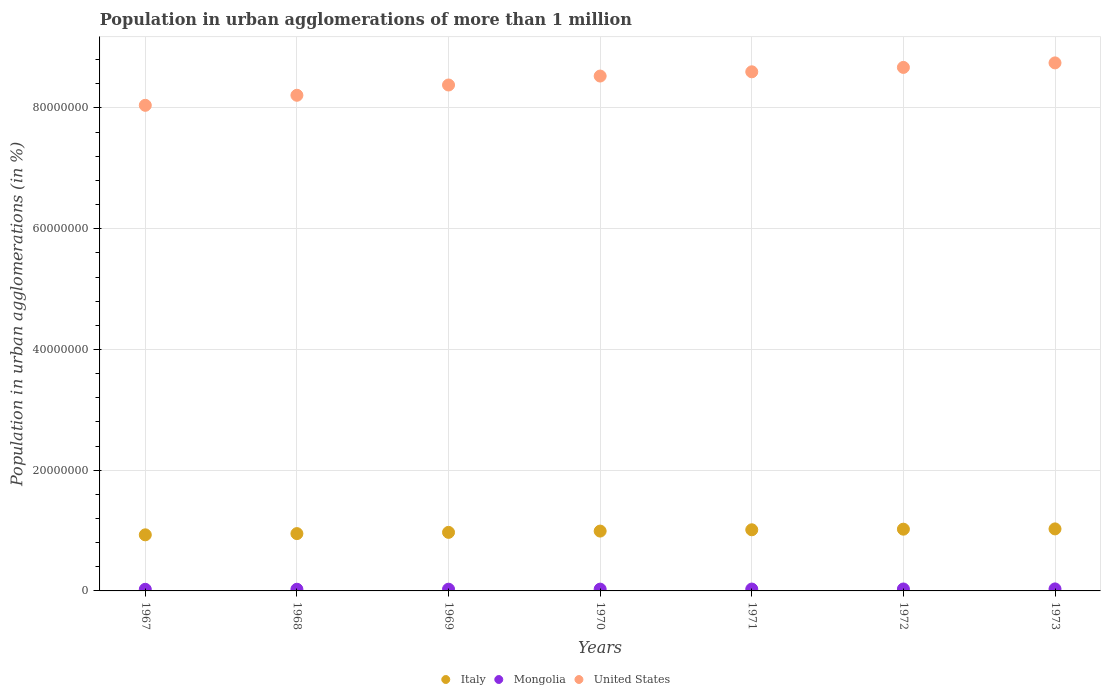Is the number of dotlines equal to the number of legend labels?
Keep it short and to the point. Yes. What is the population in urban agglomerations in United States in 1969?
Offer a very short reply. 8.38e+07. Across all years, what is the maximum population in urban agglomerations in United States?
Offer a terse response. 8.75e+07. Across all years, what is the minimum population in urban agglomerations in Mongolia?
Your answer should be compact. 2.67e+05. In which year was the population in urban agglomerations in Italy minimum?
Your answer should be compact. 1967. What is the total population in urban agglomerations in Mongolia in the graph?
Provide a succinct answer. 2.09e+06. What is the difference between the population in urban agglomerations in United States in 1967 and that in 1969?
Offer a terse response. -3.36e+06. What is the difference between the population in urban agglomerations in Mongolia in 1973 and the population in urban agglomerations in Italy in 1967?
Your answer should be compact. -8.96e+06. What is the average population in urban agglomerations in Italy per year?
Your response must be concise. 9.86e+06. In the year 1969, what is the difference between the population in urban agglomerations in United States and population in urban agglomerations in Mongolia?
Ensure brevity in your answer.  8.35e+07. What is the ratio of the population in urban agglomerations in Mongolia in 1968 to that in 1970?
Keep it short and to the point. 0.93. Is the population in urban agglomerations in Italy in 1967 less than that in 1968?
Offer a terse response. Yes. Is the difference between the population in urban agglomerations in United States in 1971 and 1972 greater than the difference between the population in urban agglomerations in Mongolia in 1971 and 1972?
Provide a short and direct response. No. What is the difference between the highest and the second highest population in urban agglomerations in Italy?
Ensure brevity in your answer.  4.61e+04. What is the difference between the highest and the lowest population in urban agglomerations in Mongolia?
Make the answer very short. 6.44e+04. Is it the case that in every year, the sum of the population in urban agglomerations in United States and population in urban agglomerations in Mongolia  is greater than the population in urban agglomerations in Italy?
Give a very brief answer. Yes. Is the population in urban agglomerations in Mongolia strictly less than the population in urban agglomerations in Italy over the years?
Your answer should be very brief. Yes. How many years are there in the graph?
Make the answer very short. 7. What is the difference between two consecutive major ticks on the Y-axis?
Provide a succinct answer. 2.00e+07. Does the graph contain any zero values?
Make the answer very short. No. What is the title of the graph?
Your response must be concise. Population in urban agglomerations of more than 1 million. Does "Turkey" appear as one of the legend labels in the graph?
Your response must be concise. No. What is the label or title of the Y-axis?
Provide a succinct answer. Population in urban agglomerations (in %). What is the Population in urban agglomerations (in %) of Italy in 1967?
Offer a terse response. 9.29e+06. What is the Population in urban agglomerations (in %) of Mongolia in 1967?
Your response must be concise. 2.67e+05. What is the Population in urban agglomerations (in %) in United States in 1967?
Make the answer very short. 8.04e+07. What is the Population in urban agglomerations (in %) in Italy in 1968?
Offer a very short reply. 9.49e+06. What is the Population in urban agglomerations (in %) of Mongolia in 1968?
Your answer should be very brief. 2.77e+05. What is the Population in urban agglomerations (in %) of United States in 1968?
Ensure brevity in your answer.  8.21e+07. What is the Population in urban agglomerations (in %) of Italy in 1969?
Offer a terse response. 9.70e+06. What is the Population in urban agglomerations (in %) in Mongolia in 1969?
Offer a terse response. 2.87e+05. What is the Population in urban agglomerations (in %) of United States in 1969?
Your answer should be very brief. 8.38e+07. What is the Population in urban agglomerations (in %) of Italy in 1970?
Your answer should be compact. 9.91e+06. What is the Population in urban agglomerations (in %) of Mongolia in 1970?
Ensure brevity in your answer.  2.98e+05. What is the Population in urban agglomerations (in %) of United States in 1970?
Your answer should be compact. 8.53e+07. What is the Population in urban agglomerations (in %) of Italy in 1971?
Make the answer very short. 1.01e+07. What is the Population in urban agglomerations (in %) in Mongolia in 1971?
Offer a very short reply. 3.08e+05. What is the Population in urban agglomerations (in %) in United States in 1971?
Provide a succinct answer. 8.60e+07. What is the Population in urban agglomerations (in %) of Italy in 1972?
Your answer should be very brief. 1.02e+07. What is the Population in urban agglomerations (in %) in Mongolia in 1972?
Make the answer very short. 3.20e+05. What is the Population in urban agglomerations (in %) in United States in 1972?
Your answer should be compact. 8.67e+07. What is the Population in urban agglomerations (in %) of Italy in 1973?
Make the answer very short. 1.03e+07. What is the Population in urban agglomerations (in %) in Mongolia in 1973?
Give a very brief answer. 3.31e+05. What is the Population in urban agglomerations (in %) of United States in 1973?
Make the answer very short. 8.75e+07. Across all years, what is the maximum Population in urban agglomerations (in %) in Italy?
Your answer should be compact. 1.03e+07. Across all years, what is the maximum Population in urban agglomerations (in %) of Mongolia?
Your response must be concise. 3.31e+05. Across all years, what is the maximum Population in urban agglomerations (in %) in United States?
Ensure brevity in your answer.  8.75e+07. Across all years, what is the minimum Population in urban agglomerations (in %) of Italy?
Give a very brief answer. 9.29e+06. Across all years, what is the minimum Population in urban agglomerations (in %) in Mongolia?
Your answer should be compact. 2.67e+05. Across all years, what is the minimum Population in urban agglomerations (in %) of United States?
Your answer should be compact. 8.04e+07. What is the total Population in urban agglomerations (in %) in Italy in the graph?
Offer a very short reply. 6.90e+07. What is the total Population in urban agglomerations (in %) in Mongolia in the graph?
Make the answer very short. 2.09e+06. What is the total Population in urban agglomerations (in %) in United States in the graph?
Give a very brief answer. 5.92e+08. What is the difference between the Population in urban agglomerations (in %) in Italy in 1967 and that in 1968?
Provide a short and direct response. -2.02e+05. What is the difference between the Population in urban agglomerations (in %) in Mongolia in 1967 and that in 1968?
Offer a very short reply. -9919. What is the difference between the Population in urban agglomerations (in %) in United States in 1967 and that in 1968?
Give a very brief answer. -1.66e+06. What is the difference between the Population in urban agglomerations (in %) in Italy in 1967 and that in 1969?
Provide a succinct answer. -4.08e+05. What is the difference between the Population in urban agglomerations (in %) of Mongolia in 1967 and that in 1969?
Your answer should be compact. -2.01e+04. What is the difference between the Population in urban agglomerations (in %) of United States in 1967 and that in 1969?
Ensure brevity in your answer.  -3.36e+06. What is the difference between the Population in urban agglomerations (in %) in Italy in 1967 and that in 1970?
Give a very brief answer. -6.20e+05. What is the difference between the Population in urban agglomerations (in %) of Mongolia in 1967 and that in 1970?
Your answer should be very brief. -3.06e+04. What is the difference between the Population in urban agglomerations (in %) in United States in 1967 and that in 1970?
Provide a succinct answer. -4.85e+06. What is the difference between the Population in urban agglomerations (in %) of Italy in 1967 and that in 1971?
Your answer should be compact. -8.36e+05. What is the difference between the Population in urban agglomerations (in %) in Mongolia in 1967 and that in 1971?
Make the answer very short. -4.15e+04. What is the difference between the Population in urban agglomerations (in %) in United States in 1967 and that in 1971?
Your response must be concise. -5.55e+06. What is the difference between the Population in urban agglomerations (in %) of Italy in 1967 and that in 1972?
Offer a terse response. -9.36e+05. What is the difference between the Population in urban agglomerations (in %) of Mongolia in 1967 and that in 1972?
Keep it short and to the point. -5.28e+04. What is the difference between the Population in urban agglomerations (in %) in United States in 1967 and that in 1972?
Your answer should be compact. -6.28e+06. What is the difference between the Population in urban agglomerations (in %) in Italy in 1967 and that in 1973?
Your response must be concise. -9.82e+05. What is the difference between the Population in urban agglomerations (in %) in Mongolia in 1967 and that in 1973?
Give a very brief answer. -6.44e+04. What is the difference between the Population in urban agglomerations (in %) of United States in 1967 and that in 1973?
Offer a very short reply. -7.03e+06. What is the difference between the Population in urban agglomerations (in %) of Italy in 1968 and that in 1969?
Make the answer very short. -2.06e+05. What is the difference between the Population in urban agglomerations (in %) of Mongolia in 1968 and that in 1969?
Ensure brevity in your answer.  -1.02e+04. What is the difference between the Population in urban agglomerations (in %) in United States in 1968 and that in 1969?
Your answer should be very brief. -1.70e+06. What is the difference between the Population in urban agglomerations (in %) of Italy in 1968 and that in 1970?
Provide a succinct answer. -4.17e+05. What is the difference between the Population in urban agglomerations (in %) in Mongolia in 1968 and that in 1970?
Provide a short and direct response. -2.07e+04. What is the difference between the Population in urban agglomerations (in %) in United States in 1968 and that in 1970?
Make the answer very short. -3.19e+06. What is the difference between the Population in urban agglomerations (in %) of Italy in 1968 and that in 1971?
Offer a terse response. -6.33e+05. What is the difference between the Population in urban agglomerations (in %) of Mongolia in 1968 and that in 1971?
Your response must be concise. -3.15e+04. What is the difference between the Population in urban agglomerations (in %) in United States in 1968 and that in 1971?
Give a very brief answer. -3.89e+06. What is the difference between the Population in urban agglomerations (in %) of Italy in 1968 and that in 1972?
Your response must be concise. -7.34e+05. What is the difference between the Population in urban agglomerations (in %) in Mongolia in 1968 and that in 1972?
Your response must be concise. -4.28e+04. What is the difference between the Population in urban agglomerations (in %) of United States in 1968 and that in 1972?
Your answer should be compact. -4.62e+06. What is the difference between the Population in urban agglomerations (in %) of Italy in 1968 and that in 1973?
Offer a very short reply. -7.80e+05. What is the difference between the Population in urban agglomerations (in %) in Mongolia in 1968 and that in 1973?
Provide a short and direct response. -5.45e+04. What is the difference between the Population in urban agglomerations (in %) in United States in 1968 and that in 1973?
Keep it short and to the point. -5.36e+06. What is the difference between the Population in urban agglomerations (in %) in Italy in 1969 and that in 1970?
Your answer should be compact. -2.11e+05. What is the difference between the Population in urban agglomerations (in %) of Mongolia in 1969 and that in 1970?
Offer a terse response. -1.05e+04. What is the difference between the Population in urban agglomerations (in %) of United States in 1969 and that in 1970?
Your answer should be compact. -1.48e+06. What is the difference between the Population in urban agglomerations (in %) in Italy in 1969 and that in 1971?
Give a very brief answer. -4.27e+05. What is the difference between the Population in urban agglomerations (in %) in Mongolia in 1969 and that in 1971?
Give a very brief answer. -2.14e+04. What is the difference between the Population in urban agglomerations (in %) of United States in 1969 and that in 1971?
Provide a short and direct response. -2.19e+06. What is the difference between the Population in urban agglomerations (in %) in Italy in 1969 and that in 1972?
Your answer should be compact. -5.28e+05. What is the difference between the Population in urban agglomerations (in %) in Mongolia in 1969 and that in 1972?
Provide a short and direct response. -3.26e+04. What is the difference between the Population in urban agglomerations (in %) of United States in 1969 and that in 1972?
Give a very brief answer. -2.91e+06. What is the difference between the Population in urban agglomerations (in %) of Italy in 1969 and that in 1973?
Offer a terse response. -5.74e+05. What is the difference between the Population in urban agglomerations (in %) in Mongolia in 1969 and that in 1973?
Provide a short and direct response. -4.43e+04. What is the difference between the Population in urban agglomerations (in %) in United States in 1969 and that in 1973?
Make the answer very short. -3.66e+06. What is the difference between the Population in urban agglomerations (in %) of Italy in 1970 and that in 1971?
Ensure brevity in your answer.  -2.16e+05. What is the difference between the Population in urban agglomerations (in %) in Mongolia in 1970 and that in 1971?
Make the answer very short. -1.09e+04. What is the difference between the Population in urban agglomerations (in %) of United States in 1970 and that in 1971?
Provide a succinct answer. -7.03e+05. What is the difference between the Population in urban agglomerations (in %) in Italy in 1970 and that in 1972?
Provide a short and direct response. -3.17e+05. What is the difference between the Population in urban agglomerations (in %) in Mongolia in 1970 and that in 1972?
Provide a short and direct response. -2.22e+04. What is the difference between the Population in urban agglomerations (in %) in United States in 1970 and that in 1972?
Your response must be concise. -1.43e+06. What is the difference between the Population in urban agglomerations (in %) of Italy in 1970 and that in 1973?
Ensure brevity in your answer.  -3.63e+05. What is the difference between the Population in urban agglomerations (in %) of Mongolia in 1970 and that in 1973?
Make the answer very short. -3.38e+04. What is the difference between the Population in urban agglomerations (in %) in United States in 1970 and that in 1973?
Keep it short and to the point. -2.18e+06. What is the difference between the Population in urban agglomerations (in %) in Italy in 1971 and that in 1972?
Ensure brevity in your answer.  -1.01e+05. What is the difference between the Population in urban agglomerations (in %) of Mongolia in 1971 and that in 1972?
Your answer should be very brief. -1.13e+04. What is the difference between the Population in urban agglomerations (in %) in United States in 1971 and that in 1972?
Make the answer very short. -7.27e+05. What is the difference between the Population in urban agglomerations (in %) in Italy in 1971 and that in 1973?
Your answer should be very brief. -1.47e+05. What is the difference between the Population in urban agglomerations (in %) in Mongolia in 1971 and that in 1973?
Make the answer very short. -2.30e+04. What is the difference between the Population in urban agglomerations (in %) in United States in 1971 and that in 1973?
Your answer should be very brief. -1.48e+06. What is the difference between the Population in urban agglomerations (in %) of Italy in 1972 and that in 1973?
Provide a succinct answer. -4.61e+04. What is the difference between the Population in urban agglomerations (in %) in Mongolia in 1972 and that in 1973?
Keep it short and to the point. -1.17e+04. What is the difference between the Population in urban agglomerations (in %) of United States in 1972 and that in 1973?
Give a very brief answer. -7.48e+05. What is the difference between the Population in urban agglomerations (in %) of Italy in 1967 and the Population in urban agglomerations (in %) of Mongolia in 1968?
Your response must be concise. 9.02e+06. What is the difference between the Population in urban agglomerations (in %) of Italy in 1967 and the Population in urban agglomerations (in %) of United States in 1968?
Your response must be concise. -7.28e+07. What is the difference between the Population in urban agglomerations (in %) in Mongolia in 1967 and the Population in urban agglomerations (in %) in United States in 1968?
Your answer should be very brief. -8.18e+07. What is the difference between the Population in urban agglomerations (in %) in Italy in 1967 and the Population in urban agglomerations (in %) in Mongolia in 1969?
Your response must be concise. 9.00e+06. What is the difference between the Population in urban agglomerations (in %) of Italy in 1967 and the Population in urban agglomerations (in %) of United States in 1969?
Provide a short and direct response. -7.45e+07. What is the difference between the Population in urban agglomerations (in %) of Mongolia in 1967 and the Population in urban agglomerations (in %) of United States in 1969?
Your answer should be very brief. -8.35e+07. What is the difference between the Population in urban agglomerations (in %) in Italy in 1967 and the Population in urban agglomerations (in %) in Mongolia in 1970?
Your response must be concise. 8.99e+06. What is the difference between the Population in urban agglomerations (in %) of Italy in 1967 and the Population in urban agglomerations (in %) of United States in 1970?
Make the answer very short. -7.60e+07. What is the difference between the Population in urban agglomerations (in %) of Mongolia in 1967 and the Population in urban agglomerations (in %) of United States in 1970?
Your answer should be compact. -8.50e+07. What is the difference between the Population in urban agglomerations (in %) in Italy in 1967 and the Population in urban agglomerations (in %) in Mongolia in 1971?
Ensure brevity in your answer.  8.98e+06. What is the difference between the Population in urban agglomerations (in %) of Italy in 1967 and the Population in urban agglomerations (in %) of United States in 1971?
Your response must be concise. -7.67e+07. What is the difference between the Population in urban agglomerations (in %) of Mongolia in 1967 and the Population in urban agglomerations (in %) of United States in 1971?
Offer a terse response. -8.57e+07. What is the difference between the Population in urban agglomerations (in %) of Italy in 1967 and the Population in urban agglomerations (in %) of Mongolia in 1972?
Your response must be concise. 8.97e+06. What is the difference between the Population in urban agglomerations (in %) of Italy in 1967 and the Population in urban agglomerations (in %) of United States in 1972?
Give a very brief answer. -7.74e+07. What is the difference between the Population in urban agglomerations (in %) of Mongolia in 1967 and the Population in urban agglomerations (in %) of United States in 1972?
Provide a succinct answer. -8.65e+07. What is the difference between the Population in urban agglomerations (in %) of Italy in 1967 and the Population in urban agglomerations (in %) of Mongolia in 1973?
Provide a succinct answer. 8.96e+06. What is the difference between the Population in urban agglomerations (in %) of Italy in 1967 and the Population in urban agglomerations (in %) of United States in 1973?
Provide a short and direct response. -7.82e+07. What is the difference between the Population in urban agglomerations (in %) of Mongolia in 1967 and the Population in urban agglomerations (in %) of United States in 1973?
Give a very brief answer. -8.72e+07. What is the difference between the Population in urban agglomerations (in %) in Italy in 1968 and the Population in urban agglomerations (in %) in Mongolia in 1969?
Your answer should be very brief. 9.21e+06. What is the difference between the Population in urban agglomerations (in %) of Italy in 1968 and the Population in urban agglomerations (in %) of United States in 1969?
Your response must be concise. -7.43e+07. What is the difference between the Population in urban agglomerations (in %) of Mongolia in 1968 and the Population in urban agglomerations (in %) of United States in 1969?
Provide a succinct answer. -8.35e+07. What is the difference between the Population in urban agglomerations (in %) in Italy in 1968 and the Population in urban agglomerations (in %) in Mongolia in 1970?
Your answer should be very brief. 9.20e+06. What is the difference between the Population in urban agglomerations (in %) in Italy in 1968 and the Population in urban agglomerations (in %) in United States in 1970?
Provide a succinct answer. -7.58e+07. What is the difference between the Population in urban agglomerations (in %) in Mongolia in 1968 and the Population in urban agglomerations (in %) in United States in 1970?
Your response must be concise. -8.50e+07. What is the difference between the Population in urban agglomerations (in %) of Italy in 1968 and the Population in urban agglomerations (in %) of Mongolia in 1971?
Offer a very short reply. 9.19e+06. What is the difference between the Population in urban agglomerations (in %) of Italy in 1968 and the Population in urban agglomerations (in %) of United States in 1971?
Your response must be concise. -7.65e+07. What is the difference between the Population in urban agglomerations (in %) of Mongolia in 1968 and the Population in urban agglomerations (in %) of United States in 1971?
Ensure brevity in your answer.  -8.57e+07. What is the difference between the Population in urban agglomerations (in %) in Italy in 1968 and the Population in urban agglomerations (in %) in Mongolia in 1972?
Provide a short and direct response. 9.17e+06. What is the difference between the Population in urban agglomerations (in %) of Italy in 1968 and the Population in urban agglomerations (in %) of United States in 1972?
Offer a terse response. -7.72e+07. What is the difference between the Population in urban agglomerations (in %) in Mongolia in 1968 and the Population in urban agglomerations (in %) in United States in 1972?
Your response must be concise. -8.64e+07. What is the difference between the Population in urban agglomerations (in %) in Italy in 1968 and the Population in urban agglomerations (in %) in Mongolia in 1973?
Offer a very short reply. 9.16e+06. What is the difference between the Population in urban agglomerations (in %) in Italy in 1968 and the Population in urban agglomerations (in %) in United States in 1973?
Make the answer very short. -7.80e+07. What is the difference between the Population in urban agglomerations (in %) of Mongolia in 1968 and the Population in urban agglomerations (in %) of United States in 1973?
Provide a succinct answer. -8.72e+07. What is the difference between the Population in urban agglomerations (in %) in Italy in 1969 and the Population in urban agglomerations (in %) in Mongolia in 1970?
Your answer should be compact. 9.40e+06. What is the difference between the Population in urban agglomerations (in %) in Italy in 1969 and the Population in urban agglomerations (in %) in United States in 1970?
Offer a terse response. -7.56e+07. What is the difference between the Population in urban agglomerations (in %) in Mongolia in 1969 and the Population in urban agglomerations (in %) in United States in 1970?
Provide a succinct answer. -8.50e+07. What is the difference between the Population in urban agglomerations (in %) of Italy in 1969 and the Population in urban agglomerations (in %) of Mongolia in 1971?
Your answer should be compact. 9.39e+06. What is the difference between the Population in urban agglomerations (in %) of Italy in 1969 and the Population in urban agglomerations (in %) of United States in 1971?
Your response must be concise. -7.63e+07. What is the difference between the Population in urban agglomerations (in %) in Mongolia in 1969 and the Population in urban agglomerations (in %) in United States in 1971?
Your response must be concise. -8.57e+07. What is the difference between the Population in urban agglomerations (in %) in Italy in 1969 and the Population in urban agglomerations (in %) in Mongolia in 1972?
Provide a short and direct response. 9.38e+06. What is the difference between the Population in urban agglomerations (in %) of Italy in 1969 and the Population in urban agglomerations (in %) of United States in 1972?
Your answer should be very brief. -7.70e+07. What is the difference between the Population in urban agglomerations (in %) of Mongolia in 1969 and the Population in urban agglomerations (in %) of United States in 1972?
Your response must be concise. -8.64e+07. What is the difference between the Population in urban agglomerations (in %) in Italy in 1969 and the Population in urban agglomerations (in %) in Mongolia in 1973?
Your response must be concise. 9.37e+06. What is the difference between the Population in urban agglomerations (in %) in Italy in 1969 and the Population in urban agglomerations (in %) in United States in 1973?
Provide a succinct answer. -7.78e+07. What is the difference between the Population in urban agglomerations (in %) in Mongolia in 1969 and the Population in urban agglomerations (in %) in United States in 1973?
Provide a succinct answer. -8.72e+07. What is the difference between the Population in urban agglomerations (in %) of Italy in 1970 and the Population in urban agglomerations (in %) of Mongolia in 1971?
Ensure brevity in your answer.  9.60e+06. What is the difference between the Population in urban agglomerations (in %) in Italy in 1970 and the Population in urban agglomerations (in %) in United States in 1971?
Offer a very short reply. -7.61e+07. What is the difference between the Population in urban agglomerations (in %) of Mongolia in 1970 and the Population in urban agglomerations (in %) of United States in 1971?
Provide a short and direct response. -8.57e+07. What is the difference between the Population in urban agglomerations (in %) of Italy in 1970 and the Population in urban agglomerations (in %) of Mongolia in 1972?
Offer a terse response. 9.59e+06. What is the difference between the Population in urban agglomerations (in %) of Italy in 1970 and the Population in urban agglomerations (in %) of United States in 1972?
Keep it short and to the point. -7.68e+07. What is the difference between the Population in urban agglomerations (in %) in Mongolia in 1970 and the Population in urban agglomerations (in %) in United States in 1972?
Make the answer very short. -8.64e+07. What is the difference between the Population in urban agglomerations (in %) in Italy in 1970 and the Population in urban agglomerations (in %) in Mongolia in 1973?
Your answer should be compact. 9.58e+06. What is the difference between the Population in urban agglomerations (in %) in Italy in 1970 and the Population in urban agglomerations (in %) in United States in 1973?
Offer a very short reply. -7.76e+07. What is the difference between the Population in urban agglomerations (in %) in Mongolia in 1970 and the Population in urban agglomerations (in %) in United States in 1973?
Ensure brevity in your answer.  -8.72e+07. What is the difference between the Population in urban agglomerations (in %) in Italy in 1971 and the Population in urban agglomerations (in %) in Mongolia in 1972?
Offer a terse response. 9.81e+06. What is the difference between the Population in urban agglomerations (in %) of Italy in 1971 and the Population in urban agglomerations (in %) of United States in 1972?
Your answer should be compact. -7.66e+07. What is the difference between the Population in urban agglomerations (in %) of Mongolia in 1971 and the Population in urban agglomerations (in %) of United States in 1972?
Your response must be concise. -8.64e+07. What is the difference between the Population in urban agglomerations (in %) in Italy in 1971 and the Population in urban agglomerations (in %) in Mongolia in 1973?
Keep it short and to the point. 9.80e+06. What is the difference between the Population in urban agglomerations (in %) of Italy in 1971 and the Population in urban agglomerations (in %) of United States in 1973?
Provide a short and direct response. -7.73e+07. What is the difference between the Population in urban agglomerations (in %) in Mongolia in 1971 and the Population in urban agglomerations (in %) in United States in 1973?
Your answer should be very brief. -8.72e+07. What is the difference between the Population in urban agglomerations (in %) of Italy in 1972 and the Population in urban agglomerations (in %) of Mongolia in 1973?
Ensure brevity in your answer.  9.90e+06. What is the difference between the Population in urban agglomerations (in %) of Italy in 1972 and the Population in urban agglomerations (in %) of United States in 1973?
Provide a succinct answer. -7.72e+07. What is the difference between the Population in urban agglomerations (in %) of Mongolia in 1972 and the Population in urban agglomerations (in %) of United States in 1973?
Make the answer very short. -8.71e+07. What is the average Population in urban agglomerations (in %) in Italy per year?
Provide a short and direct response. 9.86e+06. What is the average Population in urban agglomerations (in %) in Mongolia per year?
Ensure brevity in your answer.  2.98e+05. What is the average Population in urban agglomerations (in %) of United States per year?
Your answer should be compact. 8.45e+07. In the year 1967, what is the difference between the Population in urban agglomerations (in %) in Italy and Population in urban agglomerations (in %) in Mongolia?
Your answer should be very brief. 9.02e+06. In the year 1967, what is the difference between the Population in urban agglomerations (in %) of Italy and Population in urban agglomerations (in %) of United States?
Offer a very short reply. -7.12e+07. In the year 1967, what is the difference between the Population in urban agglomerations (in %) of Mongolia and Population in urban agglomerations (in %) of United States?
Keep it short and to the point. -8.02e+07. In the year 1968, what is the difference between the Population in urban agglomerations (in %) of Italy and Population in urban agglomerations (in %) of Mongolia?
Your response must be concise. 9.22e+06. In the year 1968, what is the difference between the Population in urban agglomerations (in %) of Italy and Population in urban agglomerations (in %) of United States?
Your response must be concise. -7.26e+07. In the year 1968, what is the difference between the Population in urban agglomerations (in %) of Mongolia and Population in urban agglomerations (in %) of United States?
Offer a very short reply. -8.18e+07. In the year 1969, what is the difference between the Population in urban agglomerations (in %) in Italy and Population in urban agglomerations (in %) in Mongolia?
Provide a short and direct response. 9.41e+06. In the year 1969, what is the difference between the Population in urban agglomerations (in %) of Italy and Population in urban agglomerations (in %) of United States?
Offer a terse response. -7.41e+07. In the year 1969, what is the difference between the Population in urban agglomerations (in %) in Mongolia and Population in urban agglomerations (in %) in United States?
Provide a short and direct response. -8.35e+07. In the year 1970, what is the difference between the Population in urban agglomerations (in %) of Italy and Population in urban agglomerations (in %) of Mongolia?
Ensure brevity in your answer.  9.61e+06. In the year 1970, what is the difference between the Population in urban agglomerations (in %) of Italy and Population in urban agglomerations (in %) of United States?
Your answer should be very brief. -7.54e+07. In the year 1970, what is the difference between the Population in urban agglomerations (in %) of Mongolia and Population in urban agglomerations (in %) of United States?
Your answer should be compact. -8.50e+07. In the year 1971, what is the difference between the Population in urban agglomerations (in %) of Italy and Population in urban agglomerations (in %) of Mongolia?
Ensure brevity in your answer.  9.82e+06. In the year 1971, what is the difference between the Population in urban agglomerations (in %) in Italy and Population in urban agglomerations (in %) in United States?
Keep it short and to the point. -7.59e+07. In the year 1971, what is the difference between the Population in urban agglomerations (in %) in Mongolia and Population in urban agglomerations (in %) in United States?
Your answer should be compact. -8.57e+07. In the year 1972, what is the difference between the Population in urban agglomerations (in %) in Italy and Population in urban agglomerations (in %) in Mongolia?
Give a very brief answer. 9.91e+06. In the year 1972, what is the difference between the Population in urban agglomerations (in %) of Italy and Population in urban agglomerations (in %) of United States?
Ensure brevity in your answer.  -7.65e+07. In the year 1972, what is the difference between the Population in urban agglomerations (in %) in Mongolia and Population in urban agglomerations (in %) in United States?
Offer a terse response. -8.64e+07. In the year 1973, what is the difference between the Population in urban agglomerations (in %) in Italy and Population in urban agglomerations (in %) in Mongolia?
Offer a very short reply. 9.94e+06. In the year 1973, what is the difference between the Population in urban agglomerations (in %) of Italy and Population in urban agglomerations (in %) of United States?
Ensure brevity in your answer.  -7.72e+07. In the year 1973, what is the difference between the Population in urban agglomerations (in %) in Mongolia and Population in urban agglomerations (in %) in United States?
Give a very brief answer. -8.71e+07. What is the ratio of the Population in urban agglomerations (in %) of Italy in 1967 to that in 1968?
Your response must be concise. 0.98. What is the ratio of the Population in urban agglomerations (in %) of Mongolia in 1967 to that in 1968?
Make the answer very short. 0.96. What is the ratio of the Population in urban agglomerations (in %) in United States in 1967 to that in 1968?
Ensure brevity in your answer.  0.98. What is the ratio of the Population in urban agglomerations (in %) in Italy in 1967 to that in 1969?
Make the answer very short. 0.96. What is the ratio of the Population in urban agglomerations (in %) in Mongolia in 1967 to that in 1969?
Provide a short and direct response. 0.93. What is the ratio of the Population in urban agglomerations (in %) in United States in 1967 to that in 1969?
Offer a very short reply. 0.96. What is the ratio of the Population in urban agglomerations (in %) of Italy in 1967 to that in 1970?
Your response must be concise. 0.94. What is the ratio of the Population in urban agglomerations (in %) in Mongolia in 1967 to that in 1970?
Offer a very short reply. 0.9. What is the ratio of the Population in urban agglomerations (in %) of United States in 1967 to that in 1970?
Give a very brief answer. 0.94. What is the ratio of the Population in urban agglomerations (in %) of Italy in 1967 to that in 1971?
Your response must be concise. 0.92. What is the ratio of the Population in urban agglomerations (in %) in Mongolia in 1967 to that in 1971?
Provide a succinct answer. 0.87. What is the ratio of the Population in urban agglomerations (in %) in United States in 1967 to that in 1971?
Ensure brevity in your answer.  0.94. What is the ratio of the Population in urban agglomerations (in %) of Italy in 1967 to that in 1972?
Offer a very short reply. 0.91. What is the ratio of the Population in urban agglomerations (in %) in Mongolia in 1967 to that in 1972?
Provide a short and direct response. 0.83. What is the ratio of the Population in urban agglomerations (in %) in United States in 1967 to that in 1972?
Give a very brief answer. 0.93. What is the ratio of the Population in urban agglomerations (in %) of Italy in 1967 to that in 1973?
Keep it short and to the point. 0.9. What is the ratio of the Population in urban agglomerations (in %) of Mongolia in 1967 to that in 1973?
Ensure brevity in your answer.  0.81. What is the ratio of the Population in urban agglomerations (in %) of United States in 1967 to that in 1973?
Make the answer very short. 0.92. What is the ratio of the Population in urban agglomerations (in %) in Italy in 1968 to that in 1969?
Your answer should be very brief. 0.98. What is the ratio of the Population in urban agglomerations (in %) of Mongolia in 1968 to that in 1969?
Provide a succinct answer. 0.96. What is the ratio of the Population in urban agglomerations (in %) of United States in 1968 to that in 1969?
Give a very brief answer. 0.98. What is the ratio of the Population in urban agglomerations (in %) in Italy in 1968 to that in 1970?
Your response must be concise. 0.96. What is the ratio of the Population in urban agglomerations (in %) in Mongolia in 1968 to that in 1970?
Ensure brevity in your answer.  0.93. What is the ratio of the Population in urban agglomerations (in %) in United States in 1968 to that in 1970?
Provide a short and direct response. 0.96. What is the ratio of the Population in urban agglomerations (in %) in Italy in 1968 to that in 1971?
Your answer should be compact. 0.94. What is the ratio of the Population in urban agglomerations (in %) of Mongolia in 1968 to that in 1971?
Your answer should be compact. 0.9. What is the ratio of the Population in urban agglomerations (in %) in United States in 1968 to that in 1971?
Provide a succinct answer. 0.95. What is the ratio of the Population in urban agglomerations (in %) of Italy in 1968 to that in 1972?
Ensure brevity in your answer.  0.93. What is the ratio of the Population in urban agglomerations (in %) of Mongolia in 1968 to that in 1972?
Your response must be concise. 0.87. What is the ratio of the Population in urban agglomerations (in %) of United States in 1968 to that in 1972?
Offer a terse response. 0.95. What is the ratio of the Population in urban agglomerations (in %) of Italy in 1968 to that in 1973?
Make the answer very short. 0.92. What is the ratio of the Population in urban agglomerations (in %) in Mongolia in 1968 to that in 1973?
Provide a short and direct response. 0.84. What is the ratio of the Population in urban agglomerations (in %) of United States in 1968 to that in 1973?
Offer a terse response. 0.94. What is the ratio of the Population in urban agglomerations (in %) of Italy in 1969 to that in 1970?
Offer a very short reply. 0.98. What is the ratio of the Population in urban agglomerations (in %) in Mongolia in 1969 to that in 1970?
Provide a succinct answer. 0.96. What is the ratio of the Population in urban agglomerations (in %) in United States in 1969 to that in 1970?
Provide a succinct answer. 0.98. What is the ratio of the Population in urban agglomerations (in %) in Italy in 1969 to that in 1971?
Provide a succinct answer. 0.96. What is the ratio of the Population in urban agglomerations (in %) in Mongolia in 1969 to that in 1971?
Make the answer very short. 0.93. What is the ratio of the Population in urban agglomerations (in %) of United States in 1969 to that in 1971?
Your answer should be very brief. 0.97. What is the ratio of the Population in urban agglomerations (in %) in Italy in 1969 to that in 1972?
Keep it short and to the point. 0.95. What is the ratio of the Population in urban agglomerations (in %) in Mongolia in 1969 to that in 1972?
Ensure brevity in your answer.  0.9. What is the ratio of the Population in urban agglomerations (in %) of United States in 1969 to that in 1972?
Ensure brevity in your answer.  0.97. What is the ratio of the Population in urban agglomerations (in %) in Italy in 1969 to that in 1973?
Your response must be concise. 0.94. What is the ratio of the Population in urban agglomerations (in %) of Mongolia in 1969 to that in 1973?
Ensure brevity in your answer.  0.87. What is the ratio of the Population in urban agglomerations (in %) of United States in 1969 to that in 1973?
Offer a very short reply. 0.96. What is the ratio of the Population in urban agglomerations (in %) in Italy in 1970 to that in 1971?
Make the answer very short. 0.98. What is the ratio of the Population in urban agglomerations (in %) of Mongolia in 1970 to that in 1971?
Provide a succinct answer. 0.96. What is the ratio of the Population in urban agglomerations (in %) of Italy in 1970 to that in 1972?
Offer a terse response. 0.97. What is the ratio of the Population in urban agglomerations (in %) of Mongolia in 1970 to that in 1972?
Provide a succinct answer. 0.93. What is the ratio of the Population in urban agglomerations (in %) of United States in 1970 to that in 1972?
Offer a terse response. 0.98. What is the ratio of the Population in urban agglomerations (in %) in Italy in 1970 to that in 1973?
Provide a succinct answer. 0.96. What is the ratio of the Population in urban agglomerations (in %) in Mongolia in 1970 to that in 1973?
Your answer should be compact. 0.9. What is the ratio of the Population in urban agglomerations (in %) in United States in 1970 to that in 1973?
Offer a very short reply. 0.98. What is the ratio of the Population in urban agglomerations (in %) of Italy in 1971 to that in 1972?
Make the answer very short. 0.99. What is the ratio of the Population in urban agglomerations (in %) in Mongolia in 1971 to that in 1972?
Provide a short and direct response. 0.96. What is the ratio of the Population in urban agglomerations (in %) of United States in 1971 to that in 1972?
Give a very brief answer. 0.99. What is the ratio of the Population in urban agglomerations (in %) of Italy in 1971 to that in 1973?
Give a very brief answer. 0.99. What is the ratio of the Population in urban agglomerations (in %) of Mongolia in 1971 to that in 1973?
Offer a very short reply. 0.93. What is the ratio of the Population in urban agglomerations (in %) of United States in 1971 to that in 1973?
Offer a terse response. 0.98. What is the ratio of the Population in urban agglomerations (in %) in Mongolia in 1972 to that in 1973?
Make the answer very short. 0.96. What is the ratio of the Population in urban agglomerations (in %) in United States in 1972 to that in 1973?
Your answer should be compact. 0.99. What is the difference between the highest and the second highest Population in urban agglomerations (in %) in Italy?
Provide a short and direct response. 4.61e+04. What is the difference between the highest and the second highest Population in urban agglomerations (in %) of Mongolia?
Keep it short and to the point. 1.17e+04. What is the difference between the highest and the second highest Population in urban agglomerations (in %) of United States?
Offer a very short reply. 7.48e+05. What is the difference between the highest and the lowest Population in urban agglomerations (in %) of Italy?
Ensure brevity in your answer.  9.82e+05. What is the difference between the highest and the lowest Population in urban agglomerations (in %) in Mongolia?
Give a very brief answer. 6.44e+04. What is the difference between the highest and the lowest Population in urban agglomerations (in %) in United States?
Give a very brief answer. 7.03e+06. 